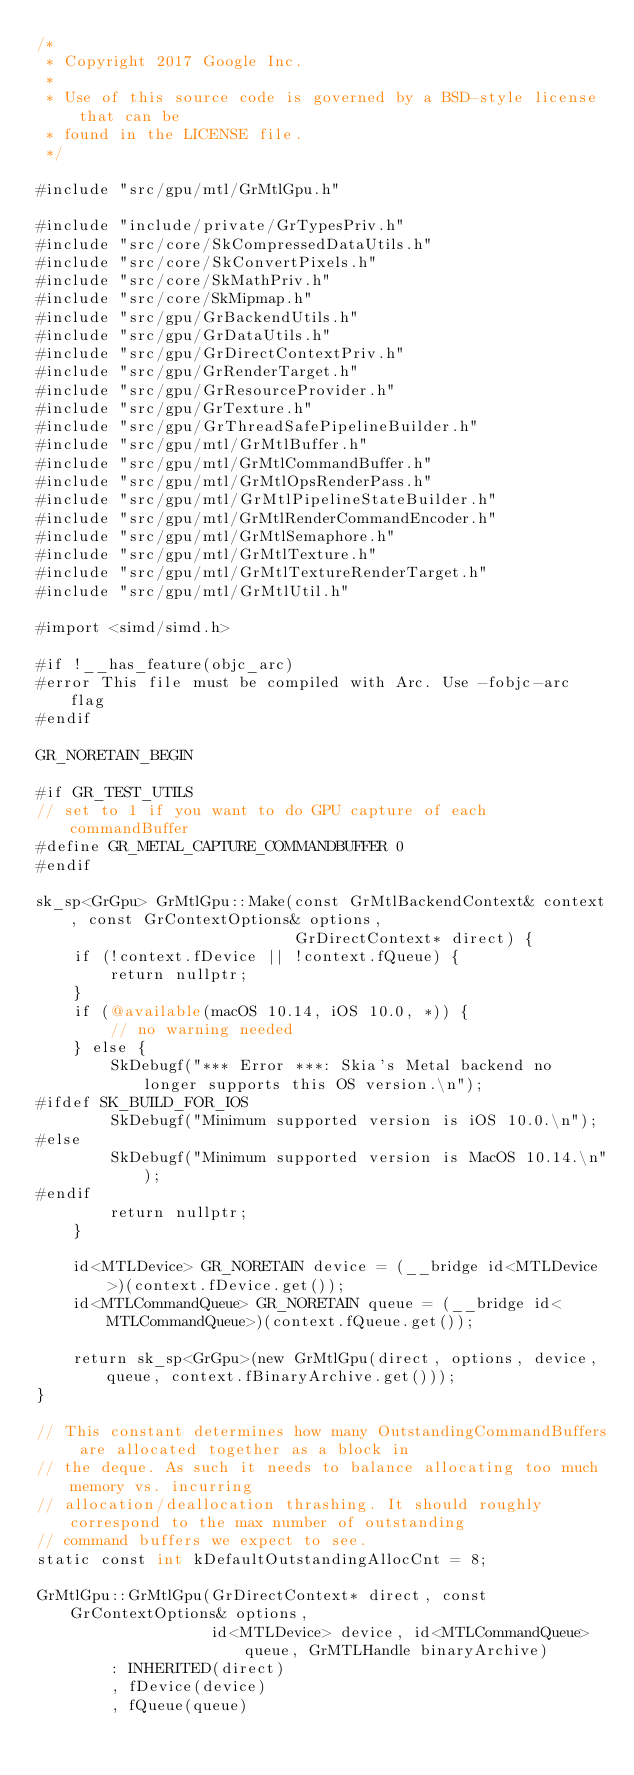<code> <loc_0><loc_0><loc_500><loc_500><_ObjectiveC_>/*
 * Copyright 2017 Google Inc.
 *
 * Use of this source code is governed by a BSD-style license that can be
 * found in the LICENSE file.
 */

#include "src/gpu/mtl/GrMtlGpu.h"

#include "include/private/GrTypesPriv.h"
#include "src/core/SkCompressedDataUtils.h"
#include "src/core/SkConvertPixels.h"
#include "src/core/SkMathPriv.h"
#include "src/core/SkMipmap.h"
#include "src/gpu/GrBackendUtils.h"
#include "src/gpu/GrDataUtils.h"
#include "src/gpu/GrDirectContextPriv.h"
#include "src/gpu/GrRenderTarget.h"
#include "src/gpu/GrResourceProvider.h"
#include "src/gpu/GrTexture.h"
#include "src/gpu/GrThreadSafePipelineBuilder.h"
#include "src/gpu/mtl/GrMtlBuffer.h"
#include "src/gpu/mtl/GrMtlCommandBuffer.h"
#include "src/gpu/mtl/GrMtlOpsRenderPass.h"
#include "src/gpu/mtl/GrMtlPipelineStateBuilder.h"
#include "src/gpu/mtl/GrMtlRenderCommandEncoder.h"
#include "src/gpu/mtl/GrMtlSemaphore.h"
#include "src/gpu/mtl/GrMtlTexture.h"
#include "src/gpu/mtl/GrMtlTextureRenderTarget.h"
#include "src/gpu/mtl/GrMtlUtil.h"

#import <simd/simd.h>

#if !__has_feature(objc_arc)
#error This file must be compiled with Arc. Use -fobjc-arc flag
#endif

GR_NORETAIN_BEGIN

#if GR_TEST_UTILS
// set to 1 if you want to do GPU capture of each commandBuffer
#define GR_METAL_CAPTURE_COMMANDBUFFER 0
#endif

sk_sp<GrGpu> GrMtlGpu::Make(const GrMtlBackendContext& context, const GrContextOptions& options,
                            GrDirectContext* direct) {
    if (!context.fDevice || !context.fQueue) {
        return nullptr;
    }
    if (@available(macOS 10.14, iOS 10.0, *)) {
        // no warning needed
    } else {
        SkDebugf("*** Error ***: Skia's Metal backend no longer supports this OS version.\n");
#ifdef SK_BUILD_FOR_IOS
        SkDebugf("Minimum supported version is iOS 10.0.\n");
#else
        SkDebugf("Minimum supported version is MacOS 10.14.\n");
#endif
        return nullptr;
    }

    id<MTLDevice> GR_NORETAIN device = (__bridge id<MTLDevice>)(context.fDevice.get());
    id<MTLCommandQueue> GR_NORETAIN queue = (__bridge id<MTLCommandQueue>)(context.fQueue.get());

    return sk_sp<GrGpu>(new GrMtlGpu(direct, options, device, queue, context.fBinaryArchive.get()));
}

// This constant determines how many OutstandingCommandBuffers are allocated together as a block in
// the deque. As such it needs to balance allocating too much memory vs. incurring
// allocation/deallocation thrashing. It should roughly correspond to the max number of outstanding
// command buffers we expect to see.
static const int kDefaultOutstandingAllocCnt = 8;

GrMtlGpu::GrMtlGpu(GrDirectContext* direct, const GrContextOptions& options,
                   id<MTLDevice> device, id<MTLCommandQueue> queue, GrMTLHandle binaryArchive)
        : INHERITED(direct)
        , fDevice(device)
        , fQueue(queue)</code> 